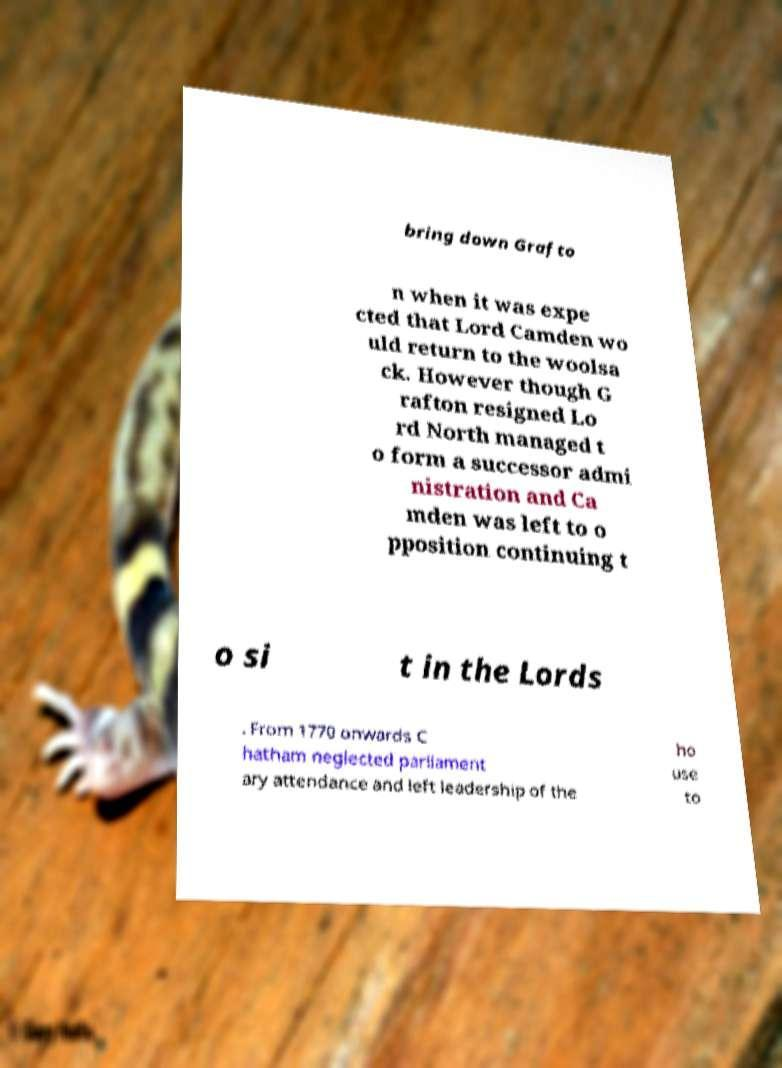Can you accurately transcribe the text from the provided image for me? bring down Grafto n when it was expe cted that Lord Camden wo uld return to the woolsa ck. However though G rafton resigned Lo rd North managed t o form a successor admi nistration and Ca mden was left to o pposition continuing t o si t in the Lords . From 1770 onwards C hatham neglected parliament ary attendance and left leadership of the ho use to 